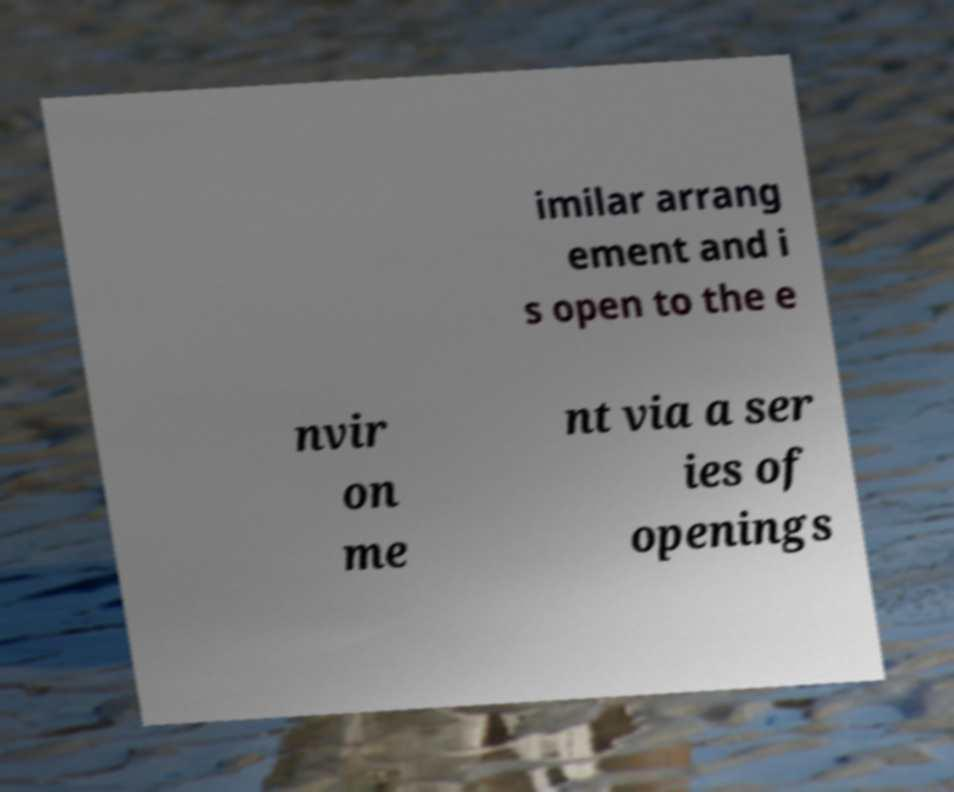For documentation purposes, I need the text within this image transcribed. Could you provide that? imilar arrang ement and i s open to the e nvir on me nt via a ser ies of openings 